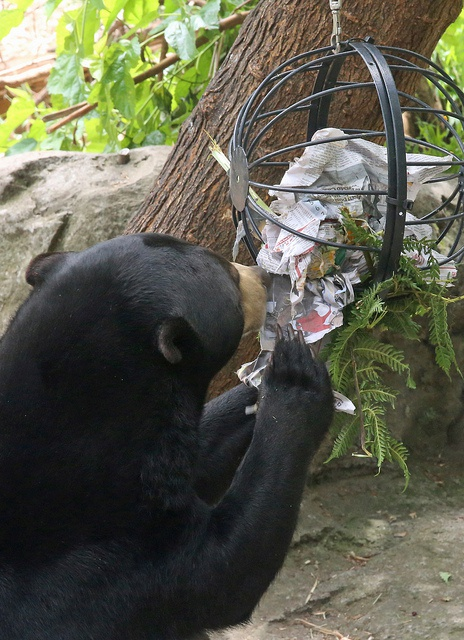Describe the objects in this image and their specific colors. I can see a bear in ivory, black, gray, and darkgreen tones in this image. 